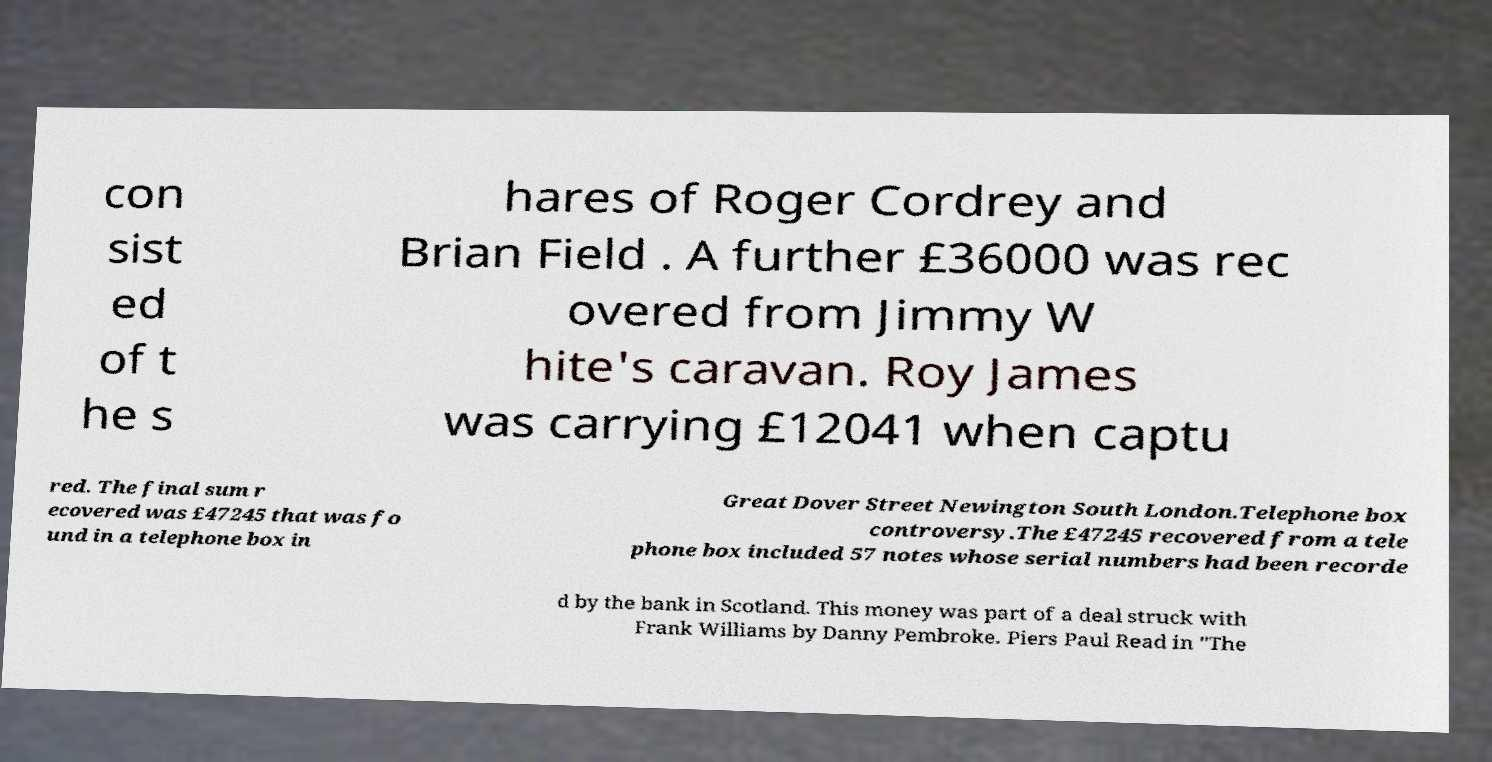Can you read and provide the text displayed in the image?This photo seems to have some interesting text. Can you extract and type it out for me? con sist ed of t he s hares of Roger Cordrey and Brian Field . A further £36000 was rec overed from Jimmy W hite's caravan. Roy James was carrying £12041 when captu red. The final sum r ecovered was £47245 that was fo und in a telephone box in Great Dover Street Newington South London.Telephone box controversy.The £47245 recovered from a tele phone box included 57 notes whose serial numbers had been recorde d by the bank in Scotland. This money was part of a deal struck with Frank Williams by Danny Pembroke. Piers Paul Read in "The 